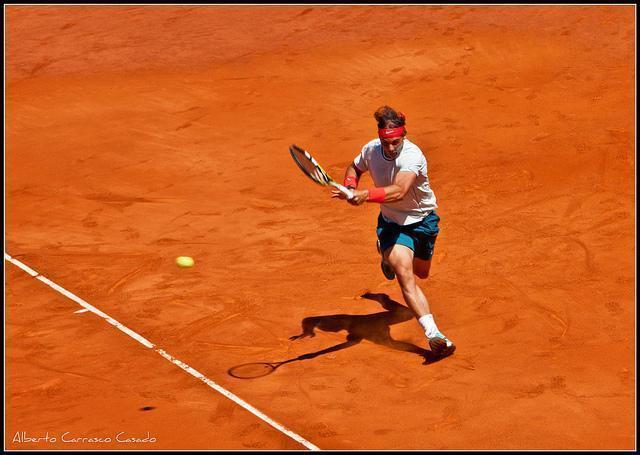Upon what surfaced court is this game being played?
Choose the right answer from the provided options to respond to the question.
Options: Asphalt, concrete, grass, clay. Clay. 